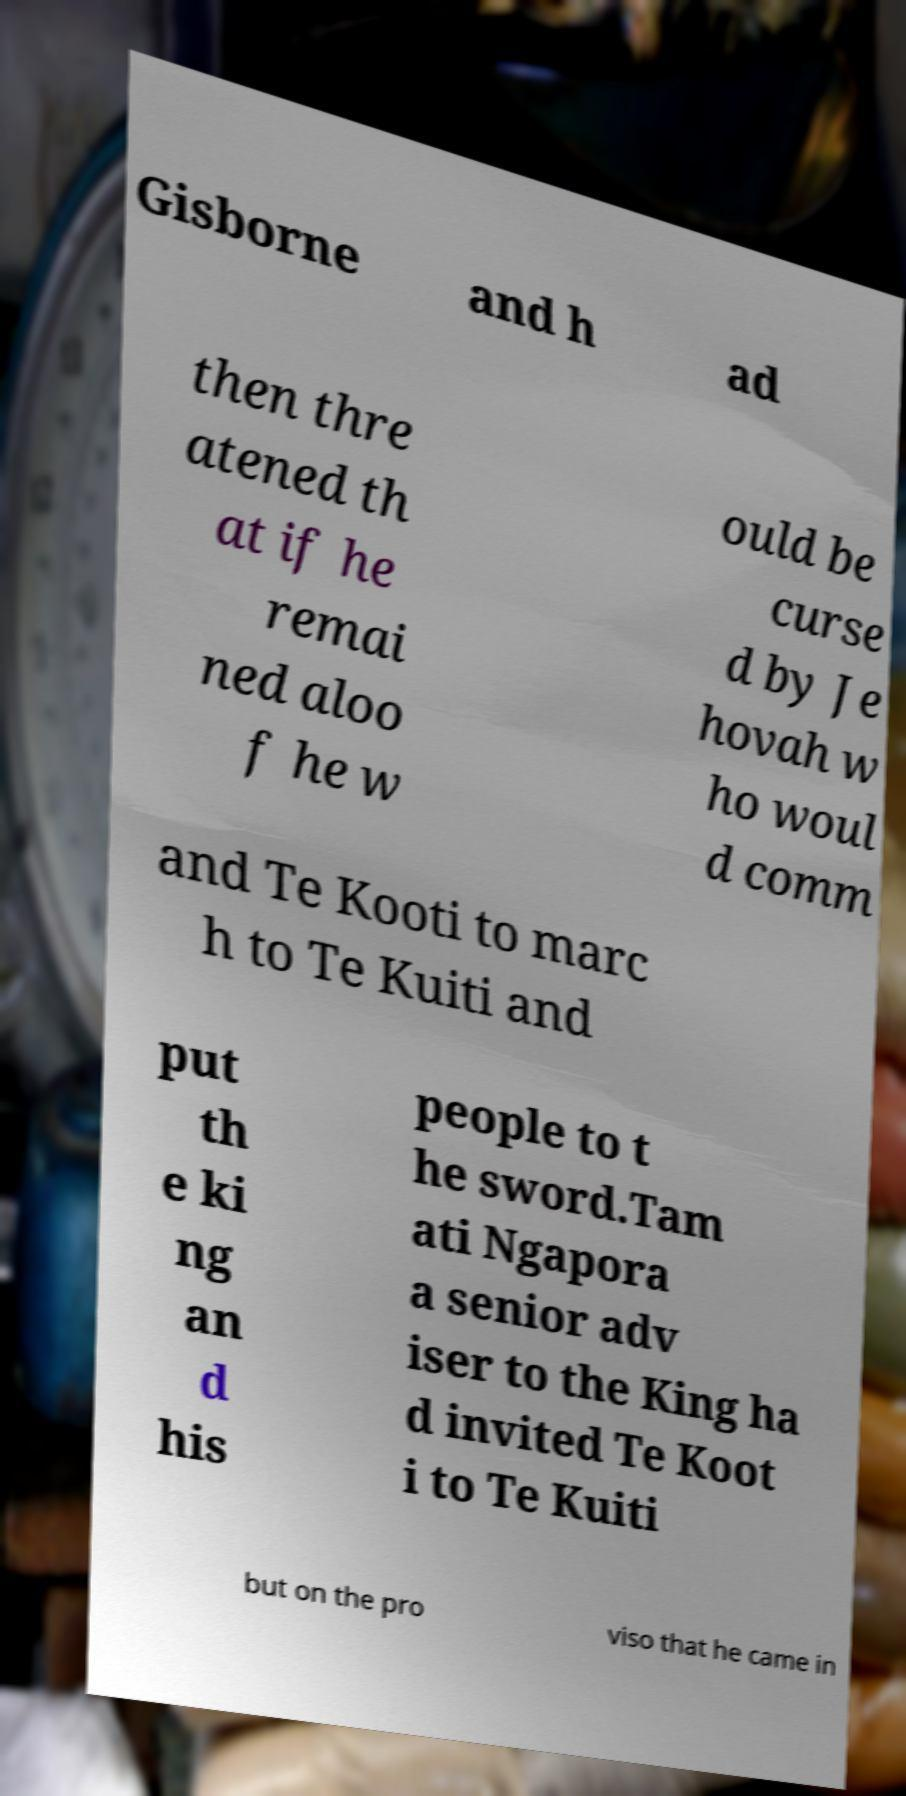Could you assist in decoding the text presented in this image and type it out clearly? Gisborne and h ad then thre atened th at if he remai ned aloo f he w ould be curse d by Je hovah w ho woul d comm and Te Kooti to marc h to Te Kuiti and put th e ki ng an d his people to t he sword.Tam ati Ngapora a senior adv iser to the King ha d invited Te Koot i to Te Kuiti but on the pro viso that he came in 